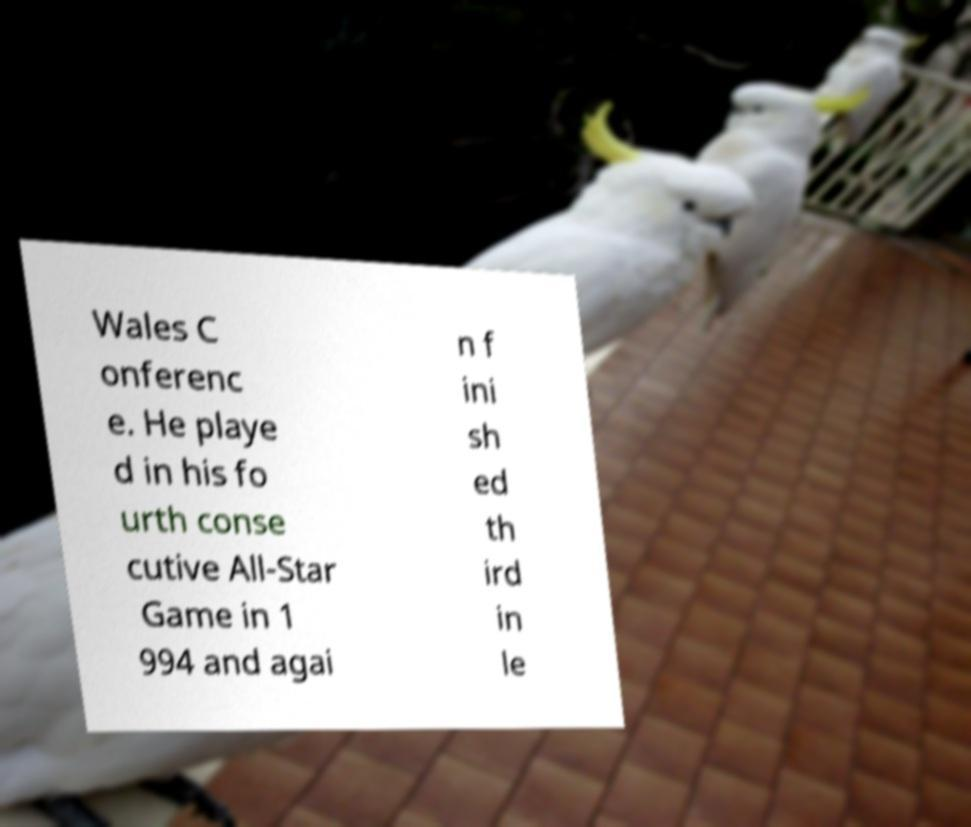Can you read and provide the text displayed in the image?This photo seems to have some interesting text. Can you extract and type it out for me? Wales C onferenc e. He playe d in his fo urth conse cutive All-Star Game in 1 994 and agai n f ini sh ed th ird in le 